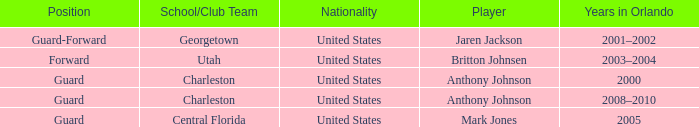What was the Position of the Player, Britton Johnsen? Forward. 